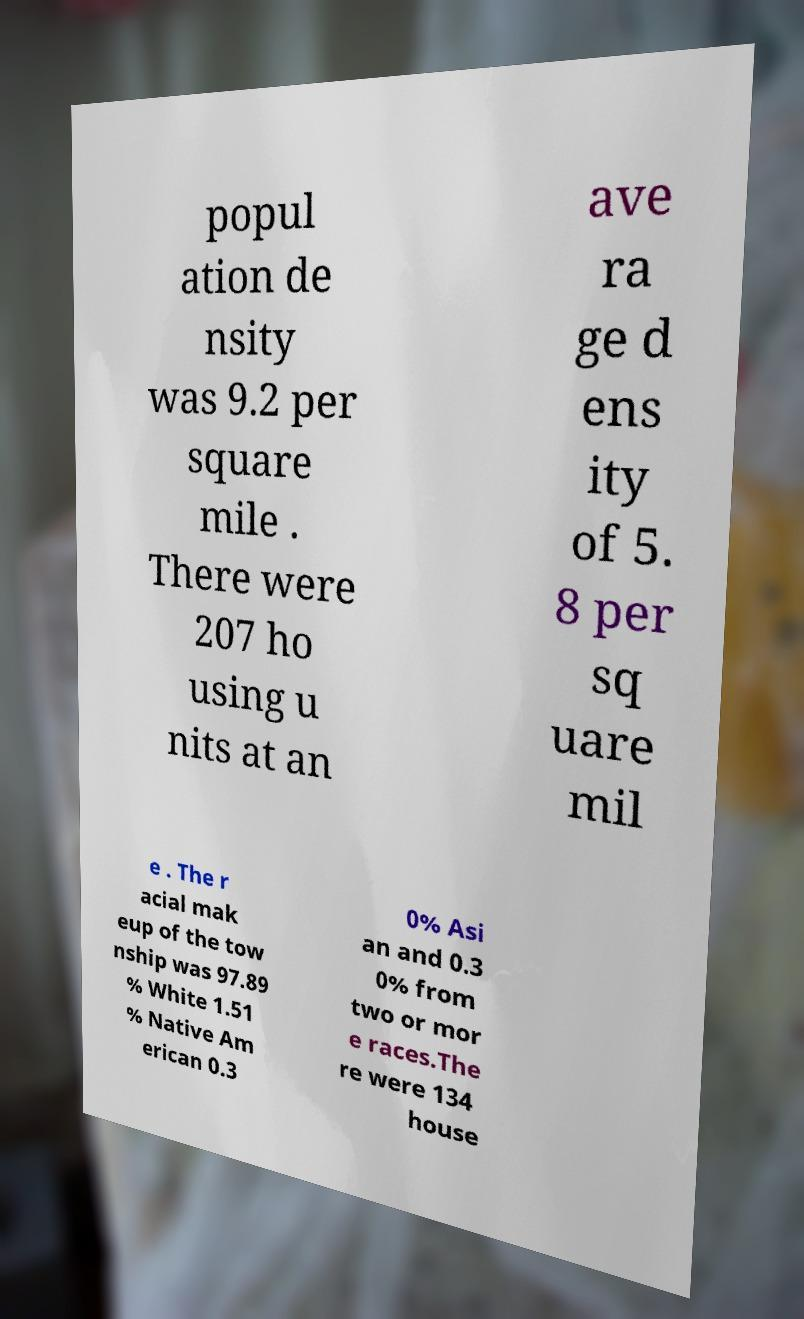Please read and relay the text visible in this image. What does it say? popul ation de nsity was 9.2 per square mile . There were 207 ho using u nits at an ave ra ge d ens ity of 5. 8 per sq uare mil e . The r acial mak eup of the tow nship was 97.89 % White 1.51 % Native Am erican 0.3 0% Asi an and 0.3 0% from two or mor e races.The re were 134 house 